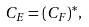Convert formula to latex. <formula><loc_0><loc_0><loc_500><loc_500>C _ { E } = ( C _ { F } ) ^ { * } ,</formula> 